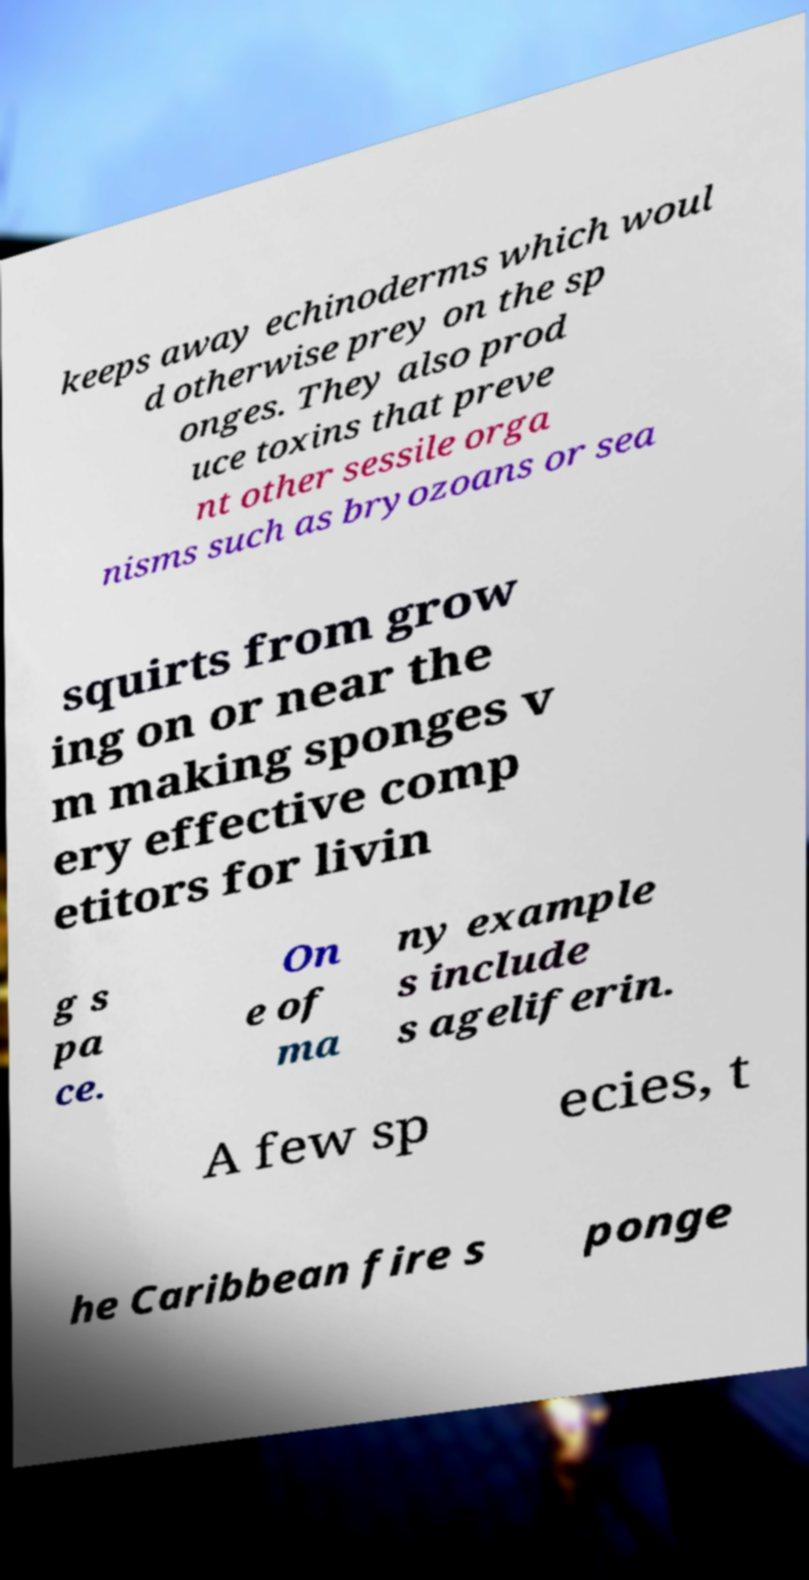Could you assist in decoding the text presented in this image and type it out clearly? keeps away echinoderms which woul d otherwise prey on the sp onges. They also prod uce toxins that preve nt other sessile orga nisms such as bryozoans or sea squirts from grow ing on or near the m making sponges v ery effective comp etitors for livin g s pa ce. On e of ma ny example s include s ageliferin. A few sp ecies, t he Caribbean fire s ponge 